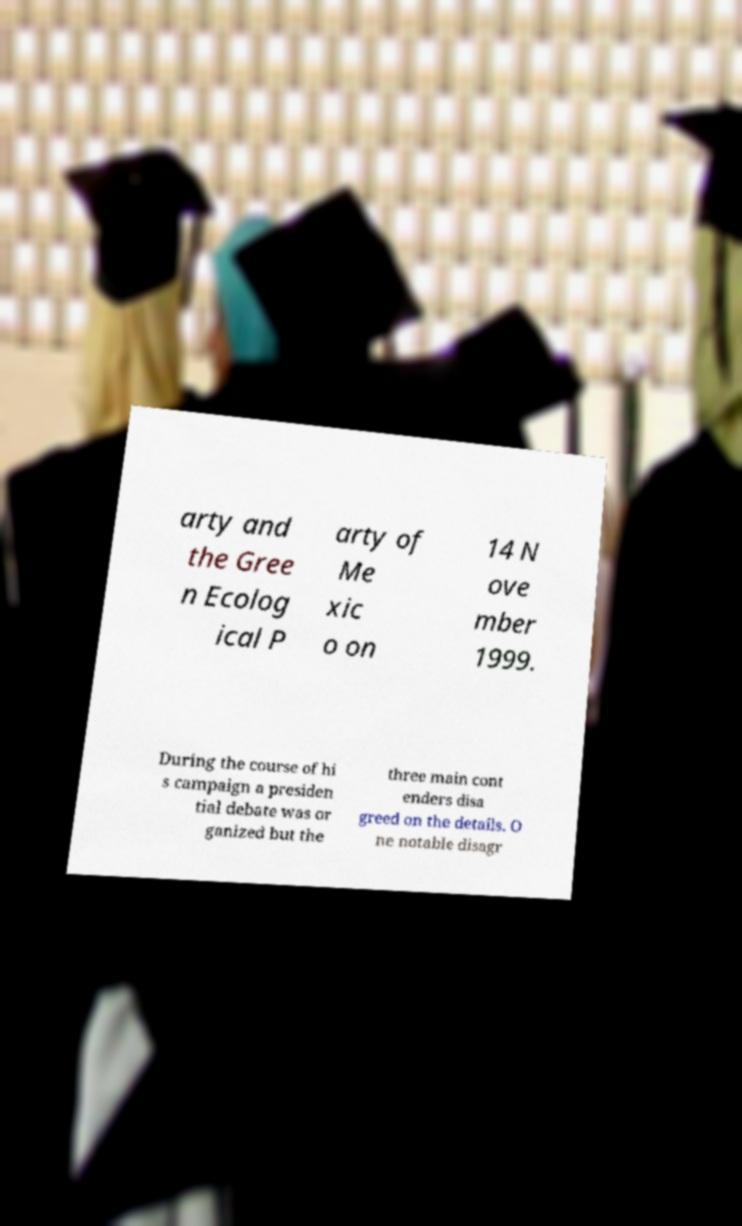Can you read and provide the text displayed in the image?This photo seems to have some interesting text. Can you extract and type it out for me? arty and the Gree n Ecolog ical P arty of Me xic o on 14 N ove mber 1999. During the course of hi s campaign a presiden tial debate was or ganized but the three main cont enders disa greed on the details. O ne notable disagr 